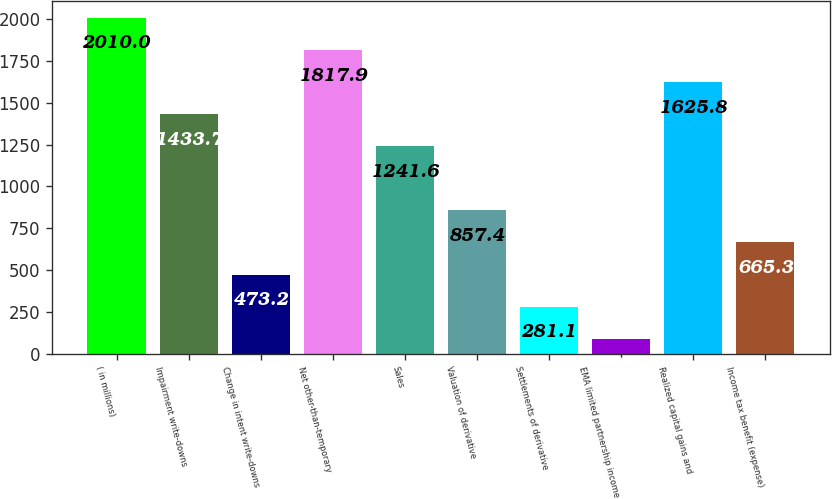Convert chart to OTSL. <chart><loc_0><loc_0><loc_500><loc_500><bar_chart><fcel>( in millions)<fcel>Impairment write-downs<fcel>Change in intent write-downs<fcel>Net other-than-temporary<fcel>Sales<fcel>Valuation of derivative<fcel>Settlements of derivative<fcel>EMA limited partnership income<fcel>Realized capital gains and<fcel>Income tax benefit (expense)<nl><fcel>2010<fcel>1433.7<fcel>473.2<fcel>1817.9<fcel>1241.6<fcel>857.4<fcel>281.1<fcel>89<fcel>1625.8<fcel>665.3<nl></chart> 